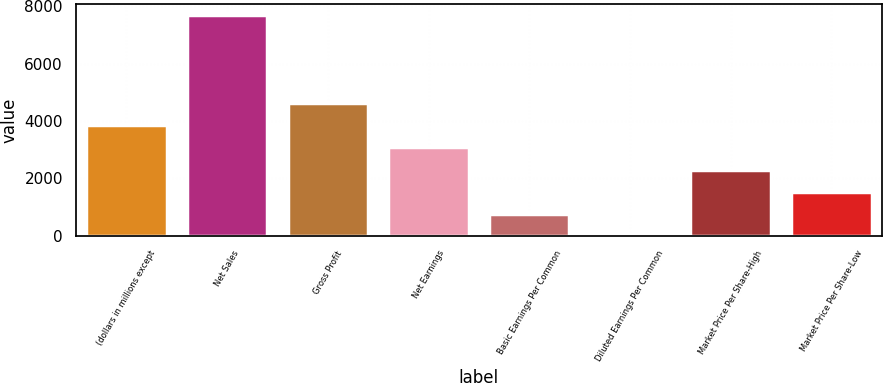Convert chart. <chart><loc_0><loc_0><loc_500><loc_500><bar_chart><fcel>(dollars in millions except<fcel>Net Sales<fcel>Gross Profit<fcel>Net Earnings<fcel>Basic Earnings Per Common<fcel>Diluted Earnings Per Common<fcel>Market Price Per Share-High<fcel>Market Price Per Share-Low<nl><fcel>3849.54<fcel>7698.4<fcel>4619.32<fcel>3079.76<fcel>770.42<fcel>0.64<fcel>2309.98<fcel>1540.2<nl></chart> 